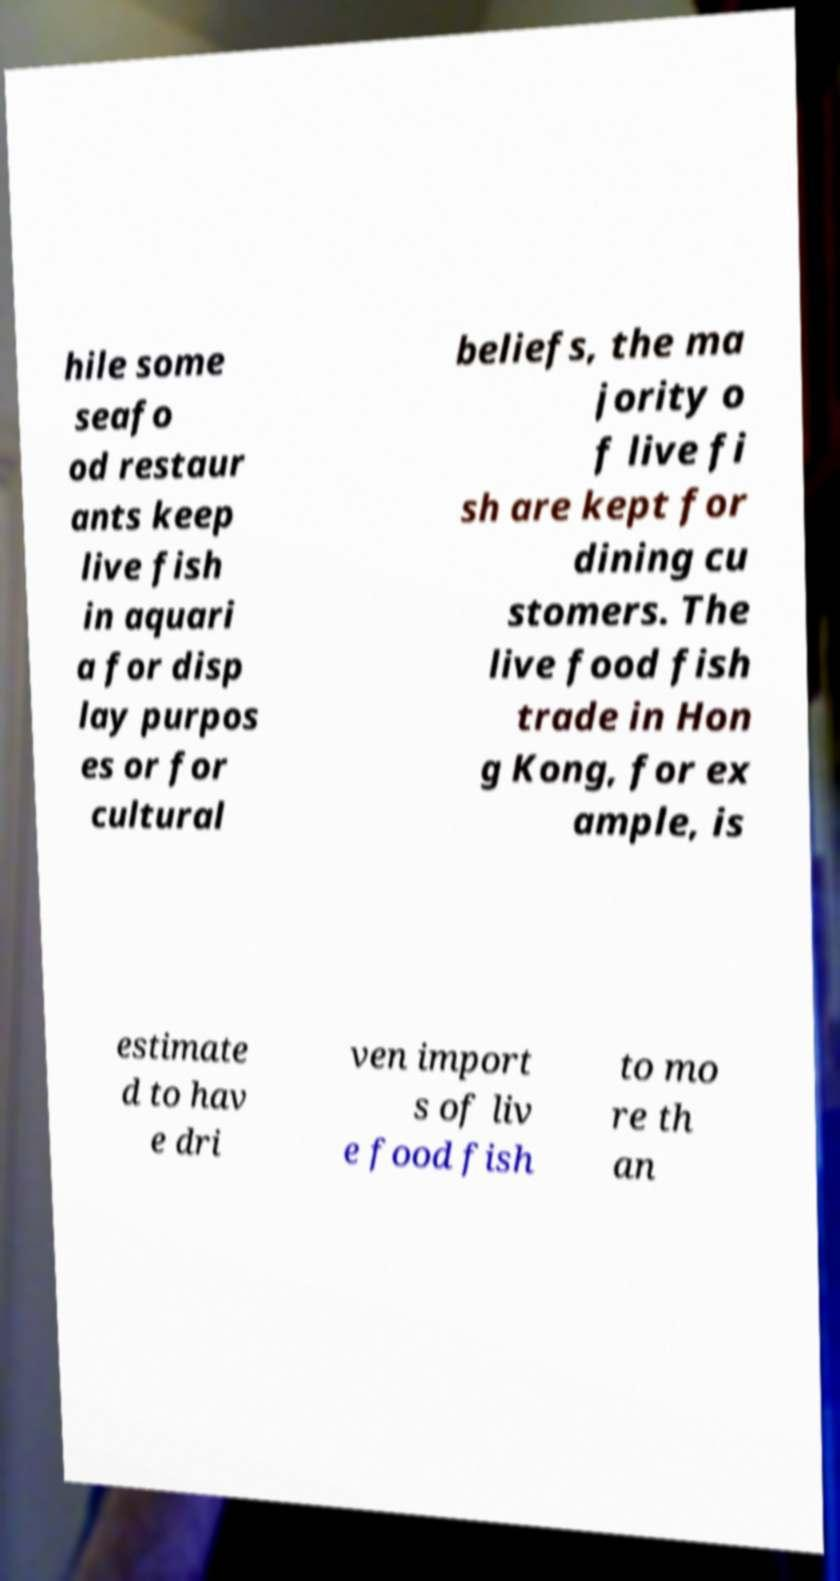Could you extract and type out the text from this image? hile some seafo od restaur ants keep live fish in aquari a for disp lay purpos es or for cultural beliefs, the ma jority o f live fi sh are kept for dining cu stomers. The live food fish trade in Hon g Kong, for ex ample, is estimate d to hav e dri ven import s of liv e food fish to mo re th an 